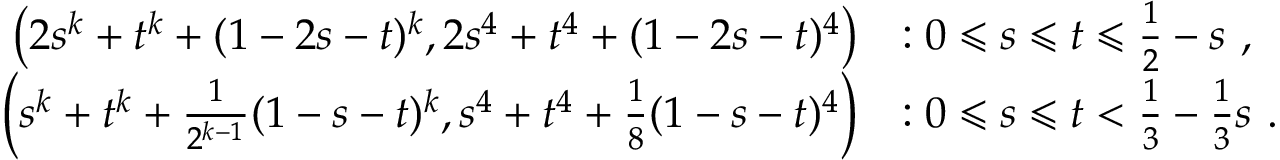Convert formula to latex. <formula><loc_0><loc_0><loc_500><loc_500>\begin{array} { r l } { \left ( 2 s ^ { k } + t ^ { k } + ( 1 - 2 s - t ) ^ { k } , 2 s ^ { 4 } + t ^ { 4 } + ( 1 - 2 s - t ) ^ { 4 } \right ) } & { \colon 0 \leqslant s \leqslant t \leqslant \frac { 1 } { 2 } - s , } \\ { \left ( s ^ { k } + t ^ { k } + \frac { 1 } { 2 ^ { k - 1 } } ( 1 - s - t ) ^ { k } , s ^ { 4 } + t ^ { 4 } + \frac { 1 } { 8 } ( 1 - s - t ) ^ { 4 } \right ) } & { \colon 0 \leqslant s \leqslant t < \frac { 1 } { 3 } - \frac { 1 } { 3 } s . } \end{array}</formula> 